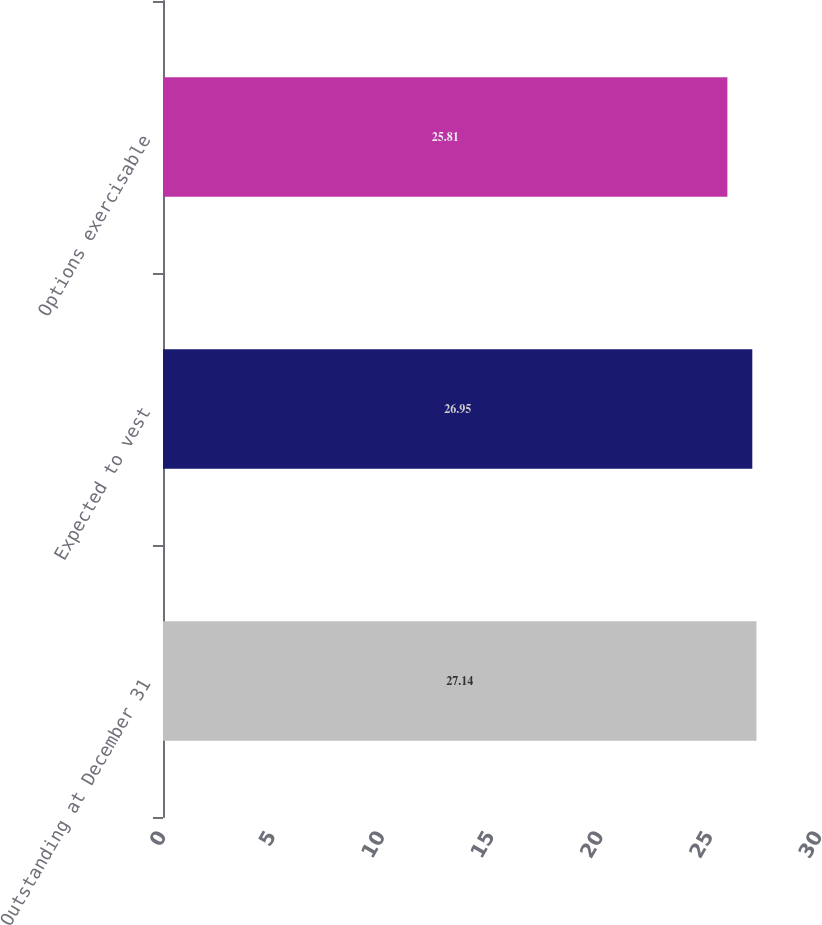Convert chart to OTSL. <chart><loc_0><loc_0><loc_500><loc_500><bar_chart><fcel>Outstanding at December 31<fcel>Expected to vest<fcel>Options exercisable<nl><fcel>27.14<fcel>26.95<fcel>25.81<nl></chart> 